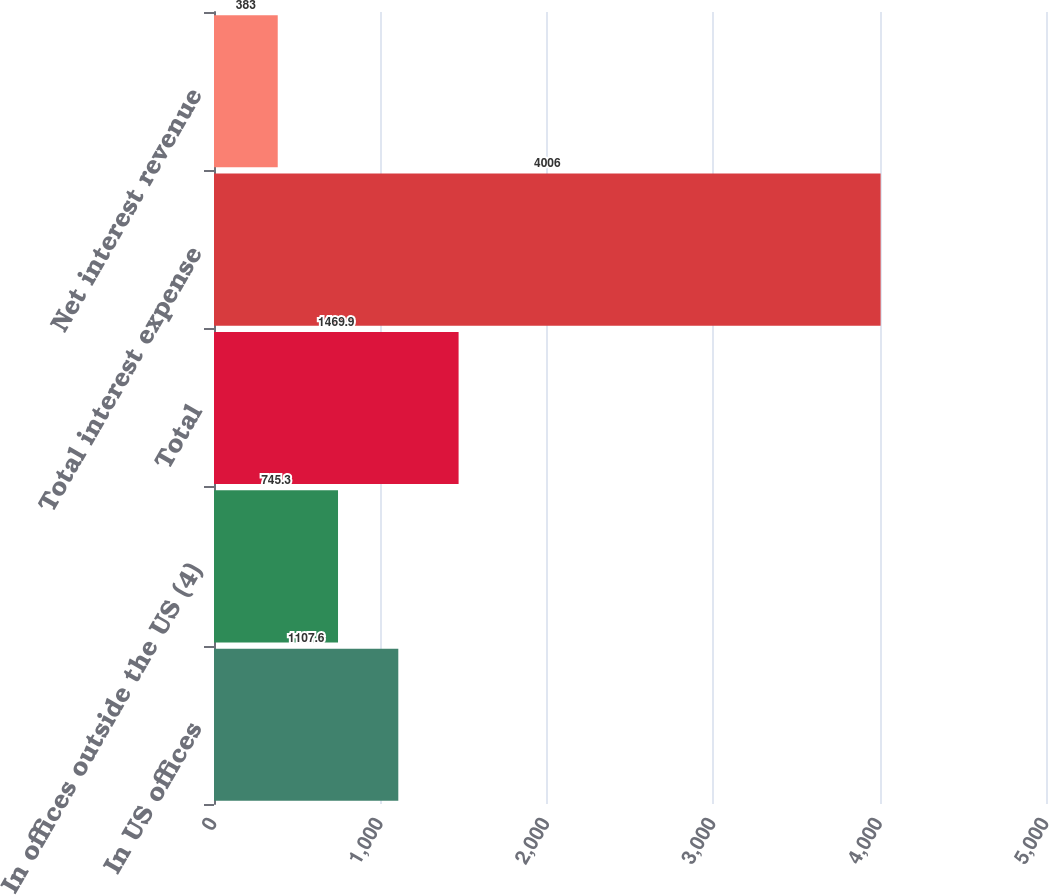<chart> <loc_0><loc_0><loc_500><loc_500><bar_chart><fcel>In US offices<fcel>In offices outside the US (4)<fcel>Total<fcel>Total interest expense<fcel>Net interest revenue<nl><fcel>1107.6<fcel>745.3<fcel>1469.9<fcel>4006<fcel>383<nl></chart> 